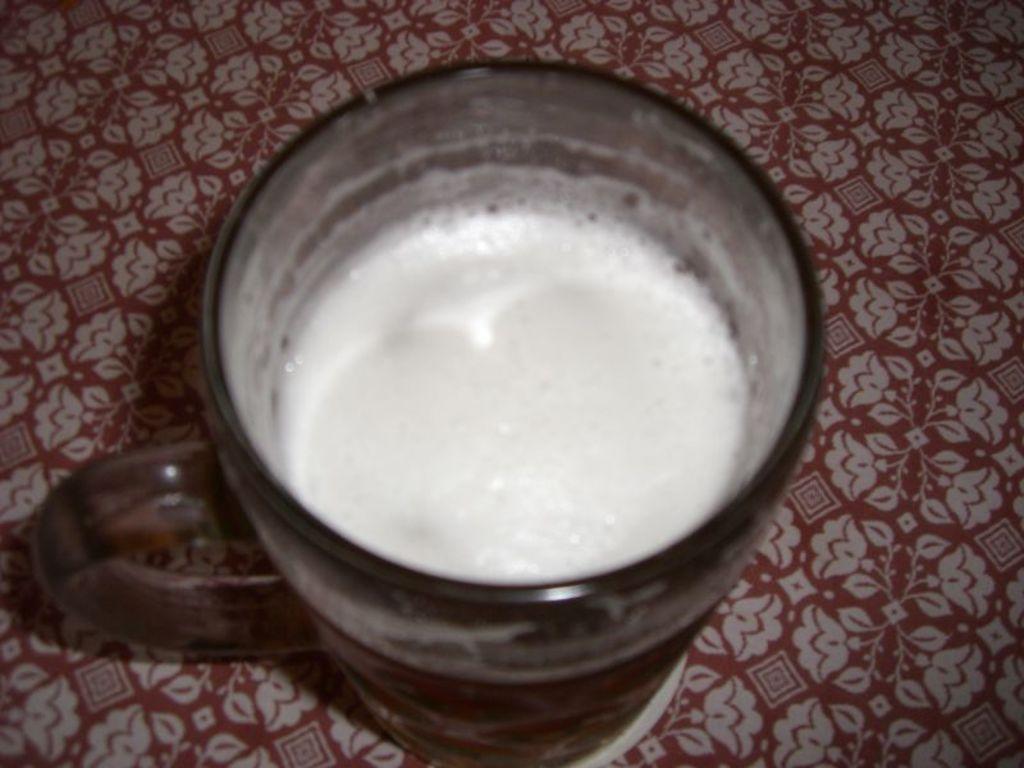Describe this image in one or two sentences. In this image, we can see a cup with liquid is placed on the surface. Here we can see a flowers print on the surface. 